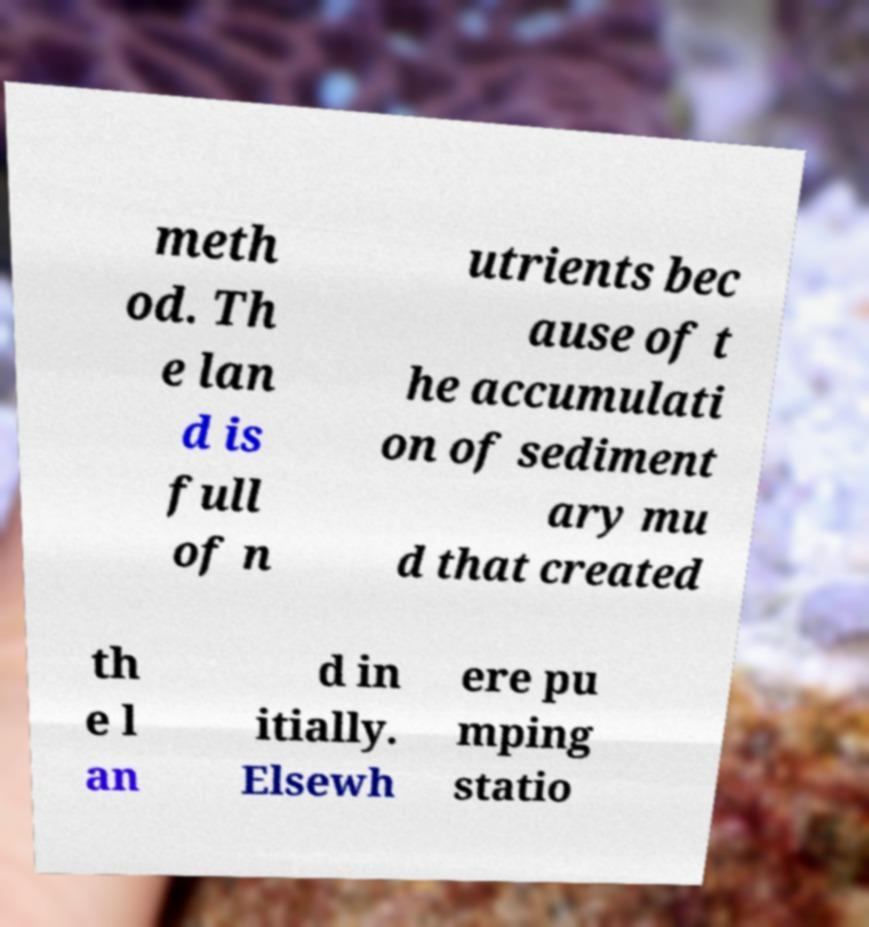Can you read and provide the text displayed in the image?This photo seems to have some interesting text. Can you extract and type it out for me? meth od. Th e lan d is full of n utrients bec ause of t he accumulati on of sediment ary mu d that created th e l an d in itially. Elsewh ere pu mping statio 